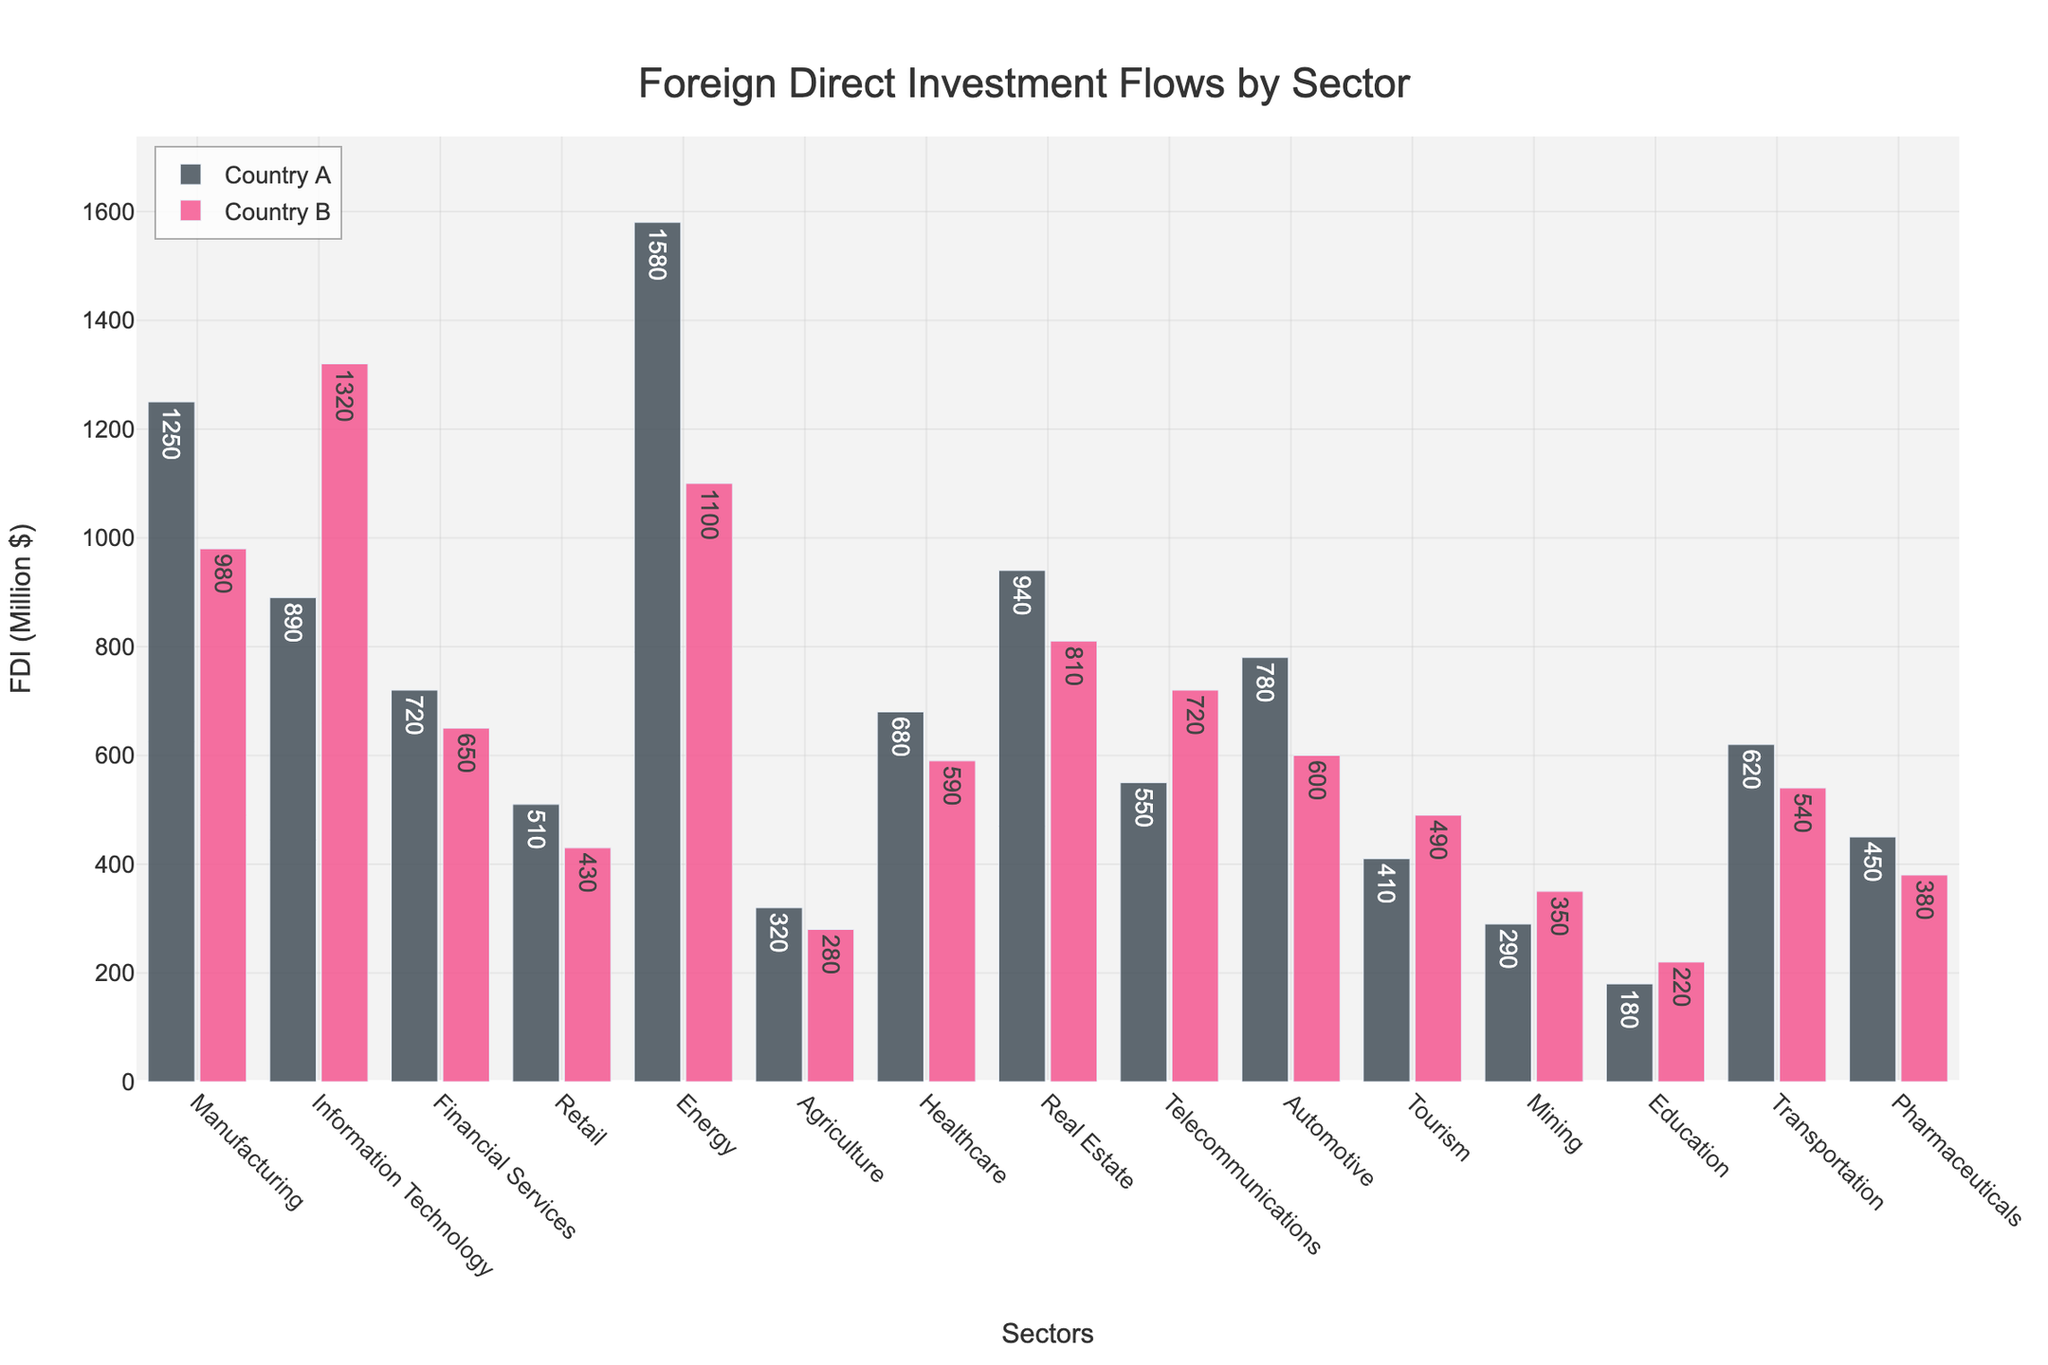What is the sector with the highest FDI from Country A? The highest bar representing Country A corresponds to the Energy sector, indicating that it has the highest FDI value from Country A.
Answer: Energy Which sectors have higher FDI from Country B than from Country A? By comparing the height of bars for both countries in each sector, Information Technology and Telecommunications are the sectors where Country B's FDI is higher than Country A's.
Answer: Information Technology, Telecommunications What is the total FDI for Transportation from both countries combined? Adding the FDI values for the Transportation sector from both countries (620 + 540) gives the total FDI in this sector.
Answer: 1160 Which country has a higher average FDI across all sectors? Calculate the average FDI for each country by summing their FDI values across all sectors and dividing by the number of sectors. Country A sum: 1250+890+720+510+1580+320+680+940+550+780+410+290+180+620+450 = 10170. Country B sum: 980+1320+650+430+1100+280+590+810+720+600+490+350+220+540+380 = 9460. Averages: 10170/15 = 678, 9460/15 = 630.7, thus Country A has a higher average FDI.
Answer: Country A What is the difference in FDI between the Manufacturing and Real Estate sectors for Country B? Subtract the FDI value for Real Estate from Manufacturing for Country B (980 - 810).
Answer: 170 On average, how much more does Country A invest in Financial Services and Retail compared to Country B? Compute the individual differences between Country A and Country B for Financial Services (720 - 650) and Retail (510 - 430), sum them and then compute the average. (70 + 80)/2 = 75.
Answer: 75 How does the FDI in Healthcare compare between the two countries? Country A's Healthcare bar is taller than Country B's. FDI values: 680 (Country A) and 590 (Country B). Thus, Country A invests more in Healthcare.
Answer: Country A invests more What is the median FDI value for all sectors for Country A? List all FDI values for Country A, sort them: [180, 290, 320, 410, 450, 510, 550, 620, 680, 720, 780, 890, 940, 1250, 1580]. The median is the middle value, which is the 8th value in this ordered list.
Answer: 620 In which sector do both countries invest the least? The shortest bars across all sectors are from the Education sector. FDI values: 180 (Country A) and 220 (Country B). Thus, both countries invest the least in Education.
Answer: Education What is the combined FDI in the Tourism and Mining sectors by both countries? Add the FDI values for both countries in the Tourism and Mining sectors: (410+490) + (290+350) = 900 + 640.
Answer: 1540 